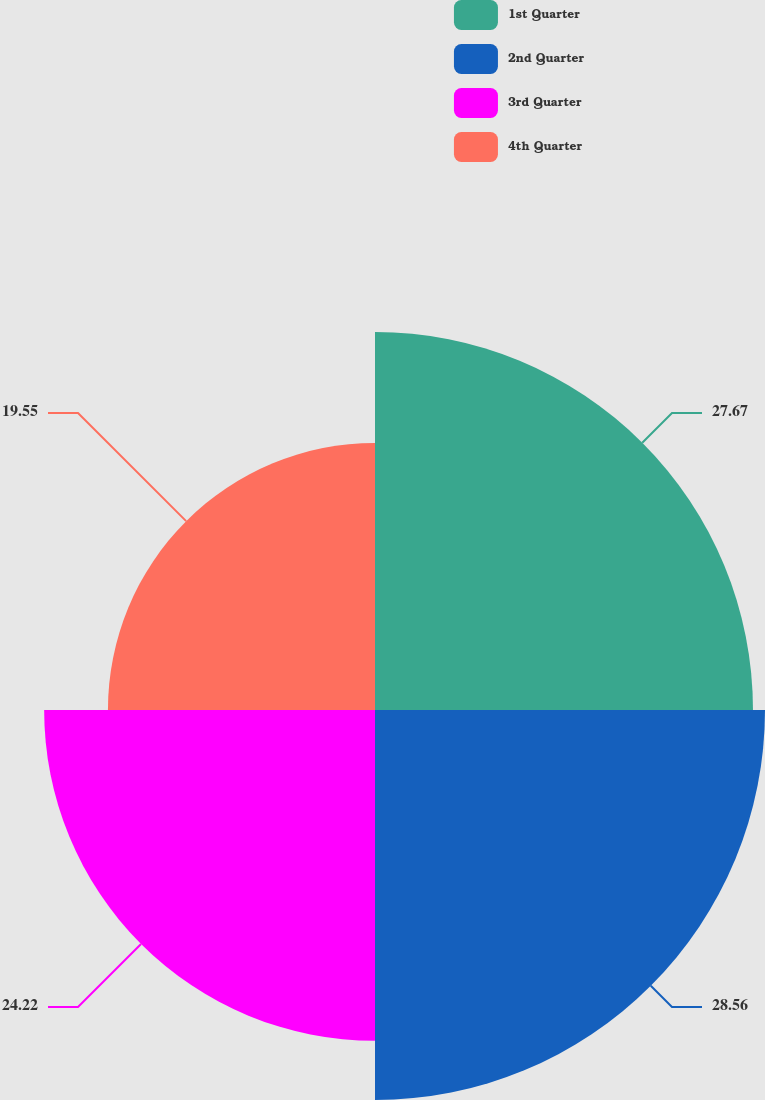Convert chart to OTSL. <chart><loc_0><loc_0><loc_500><loc_500><pie_chart><fcel>1st Quarter<fcel>2nd Quarter<fcel>3rd Quarter<fcel>4th Quarter<nl><fcel>27.67%<fcel>28.55%<fcel>24.22%<fcel>19.55%<nl></chart> 